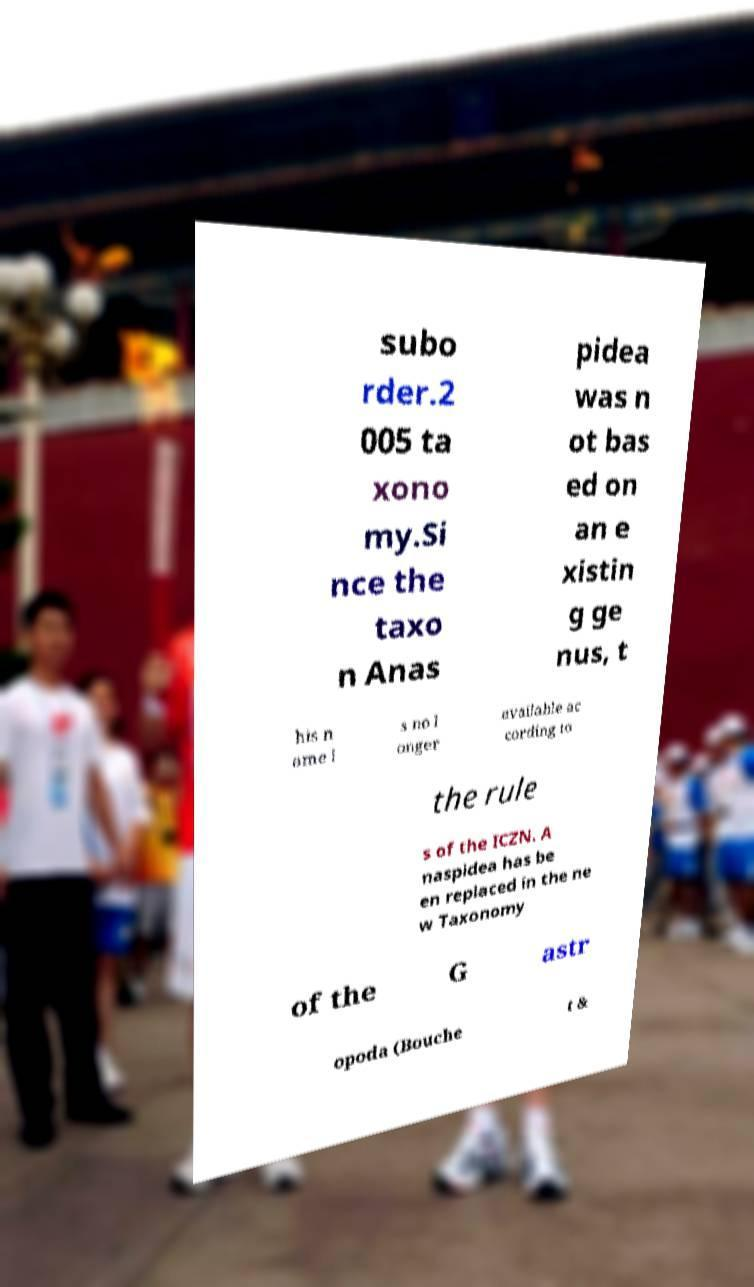Can you accurately transcribe the text from the provided image for me? subo rder.2 005 ta xono my.Si nce the taxo n Anas pidea was n ot bas ed on an e xistin g ge nus, t his n ame i s no l onger available ac cording to the rule s of the ICZN. A naspidea has be en replaced in the ne w Taxonomy of the G astr opoda (Bouche t & 